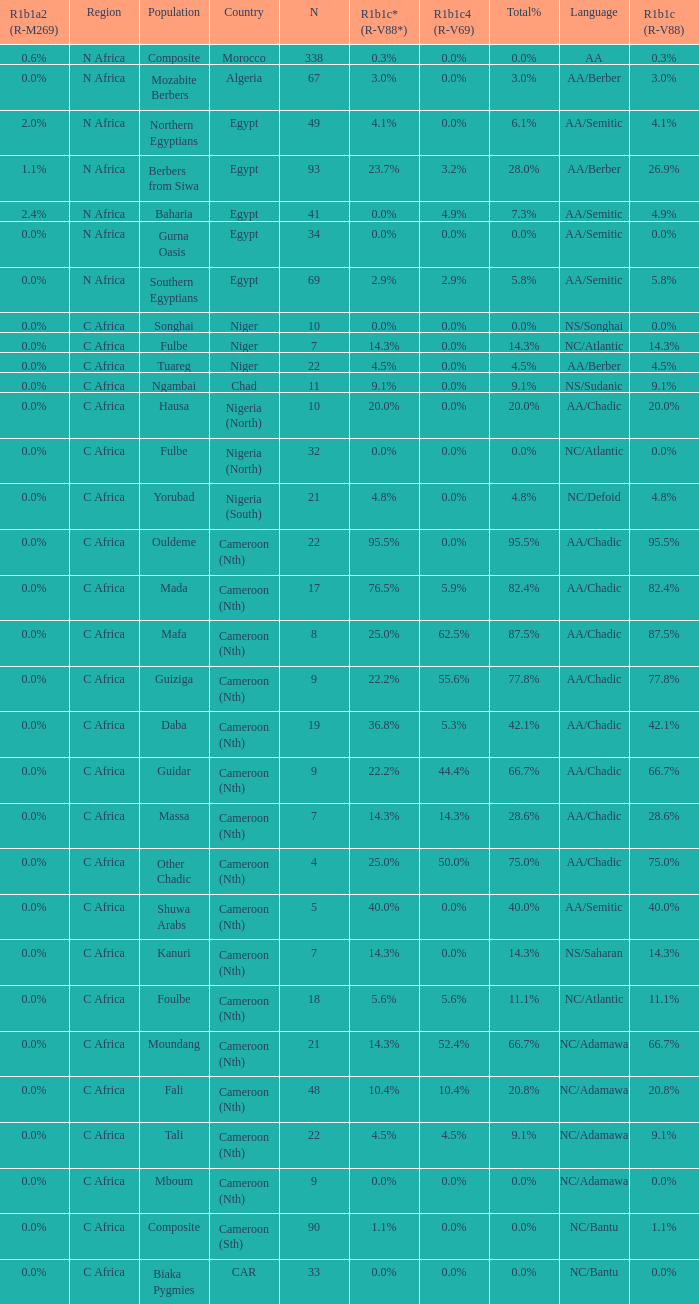What proportion is mentioned in column r1b1c (r-v88) for the 4.5%. 